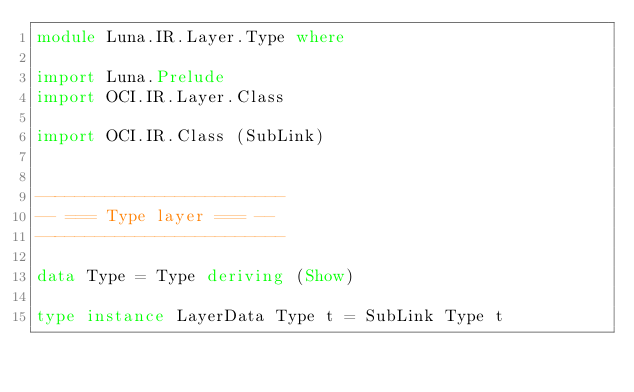Convert code to text. <code><loc_0><loc_0><loc_500><loc_500><_Haskell_>module Luna.IR.Layer.Type where

import Luna.Prelude
import OCI.IR.Layer.Class

import OCI.IR.Class (SubLink)


-------------------------
-- === Type layer === --
-------------------------

data Type = Type deriving (Show)

type instance LayerData Type t = SubLink Type t
</code> 